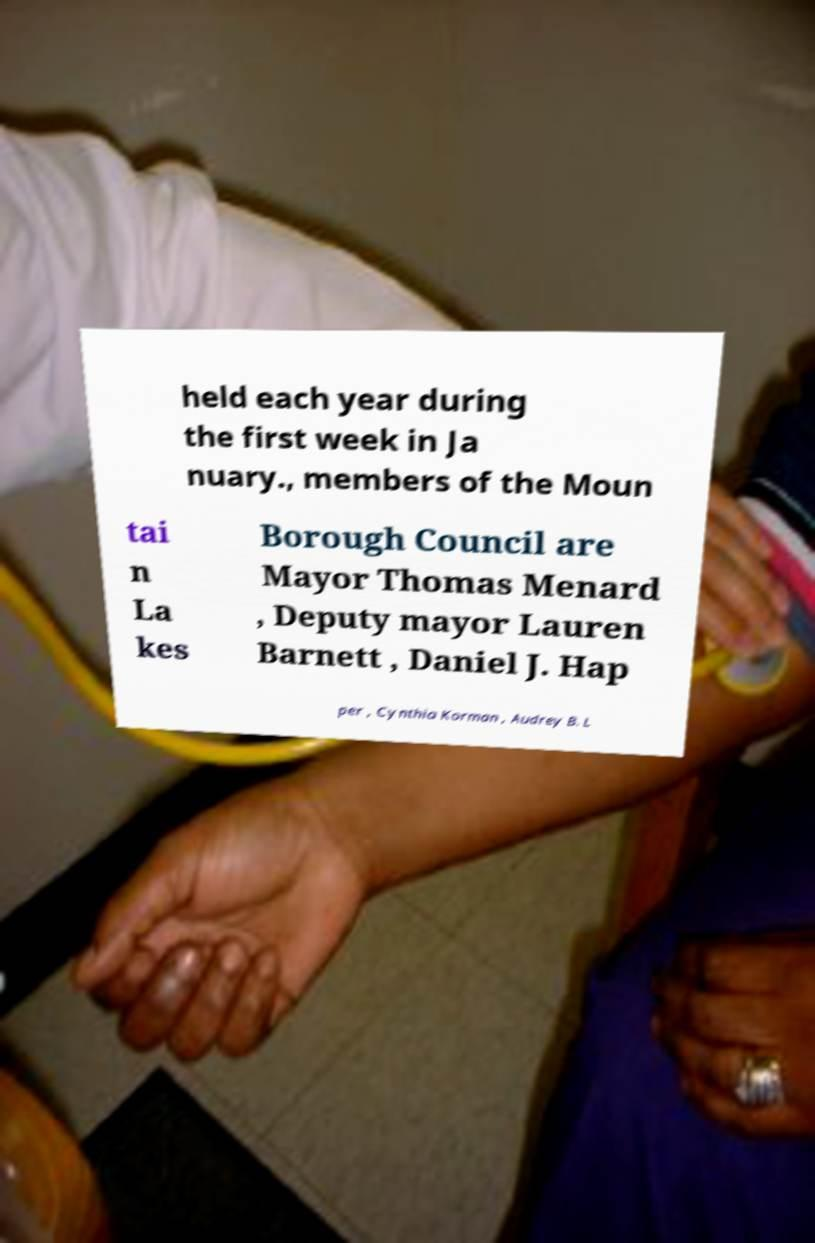Can you read and provide the text displayed in the image?This photo seems to have some interesting text. Can you extract and type it out for me? held each year during the first week in Ja nuary., members of the Moun tai n La kes Borough Council are Mayor Thomas Menard , Deputy mayor Lauren Barnett , Daniel J. Hap per , Cynthia Korman , Audrey B. L 